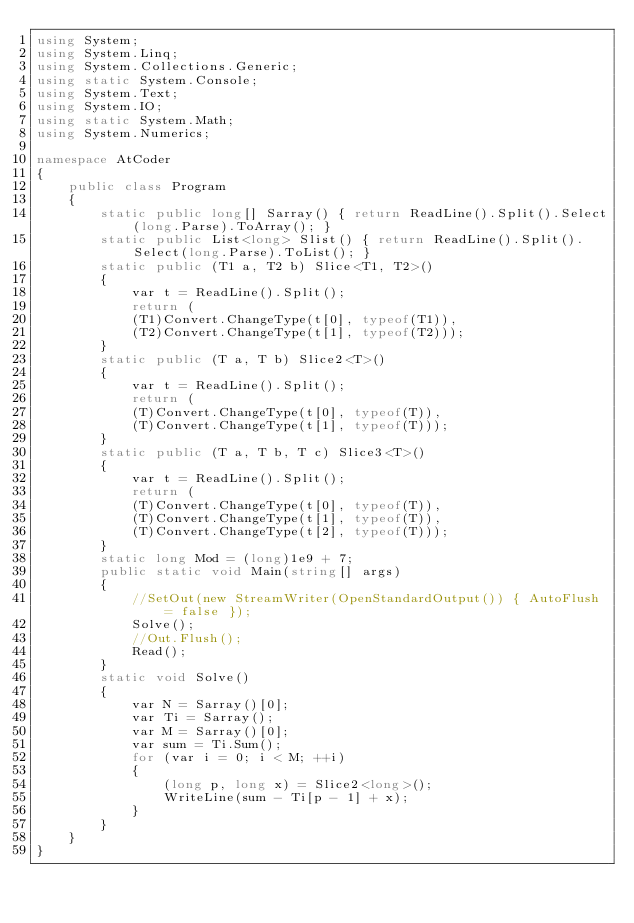<code> <loc_0><loc_0><loc_500><loc_500><_C#_>using System;
using System.Linq;
using System.Collections.Generic;
using static System.Console;
using System.Text;
using System.IO;
using static System.Math;
using System.Numerics;

namespace AtCoder
{
    public class Program
    {
        static public long[] Sarray() { return ReadLine().Split().Select(long.Parse).ToArray(); }
        static public List<long> Slist() { return ReadLine().Split().Select(long.Parse).ToList(); }
        static public (T1 a, T2 b) Slice<T1, T2>()
        {
            var t = ReadLine().Split();
            return (
            (T1)Convert.ChangeType(t[0], typeof(T1)),
            (T2)Convert.ChangeType(t[1], typeof(T2)));
        }
        static public (T a, T b) Slice2<T>()
        {
            var t = ReadLine().Split();
            return (
            (T)Convert.ChangeType(t[0], typeof(T)),
            (T)Convert.ChangeType(t[1], typeof(T)));
        }
        static public (T a, T b, T c) Slice3<T>()
        {
            var t = ReadLine().Split();
            return (
            (T)Convert.ChangeType(t[0], typeof(T)),
            (T)Convert.ChangeType(t[1], typeof(T)),
            (T)Convert.ChangeType(t[2], typeof(T)));
        }
        static long Mod = (long)1e9 + 7;
        public static void Main(string[] args)
        {
            //SetOut(new StreamWriter(OpenStandardOutput()) { AutoFlush = false });
            Solve();
            //Out.Flush();
            Read();
        }
        static void Solve()
        {
            var N = Sarray()[0];
            var Ti = Sarray();
            var M = Sarray()[0];
            var sum = Ti.Sum();
            for (var i = 0; i < M; ++i)
            {
                (long p, long x) = Slice2<long>();
                WriteLine(sum - Ti[p - 1] + x);
            }
        }
    }
}</code> 